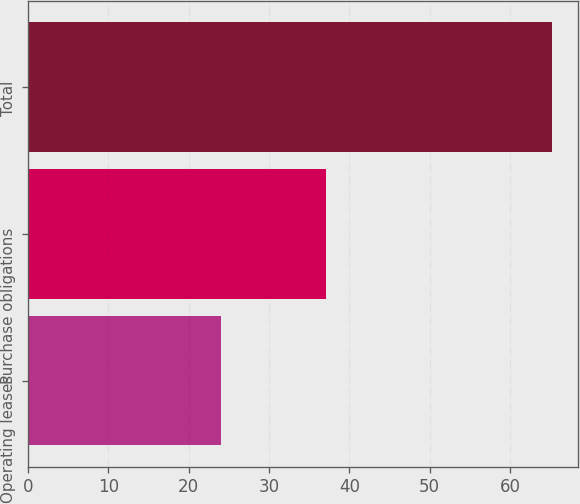Convert chart. <chart><loc_0><loc_0><loc_500><loc_500><bar_chart><fcel>Operating leases<fcel>Purchase obligations<fcel>Total<nl><fcel>24<fcel>37.1<fcel>65.2<nl></chart> 